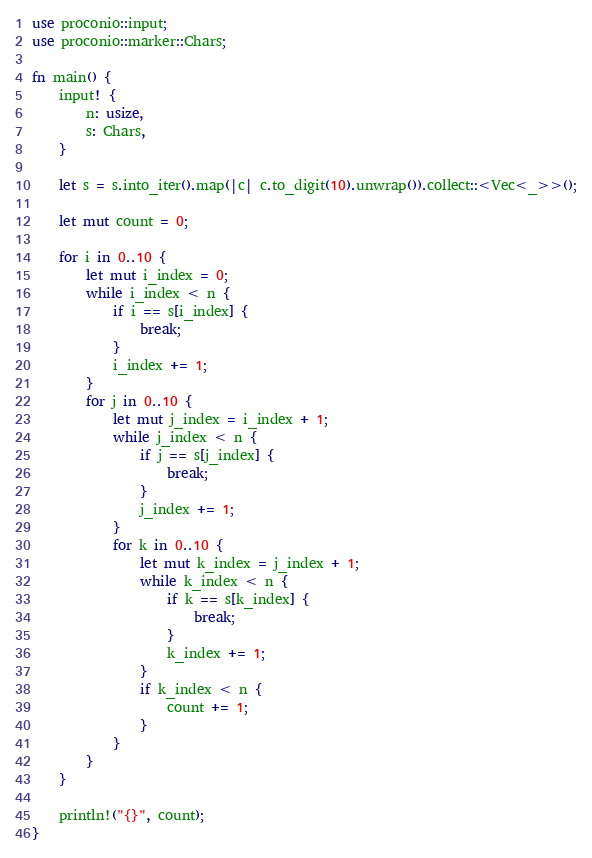Convert code to text. <code><loc_0><loc_0><loc_500><loc_500><_Rust_>use proconio::input;
use proconio::marker::Chars;

fn main() {
    input! {
        n: usize,
        s: Chars,
    }

    let s = s.into_iter().map(|c| c.to_digit(10).unwrap()).collect::<Vec<_>>();

    let mut count = 0;

    for i in 0..10 {
        let mut i_index = 0;
        while i_index < n {
            if i == s[i_index] {
                break;
            }
            i_index += 1;
        }
        for j in 0..10 {
            let mut j_index = i_index + 1;
            while j_index < n {
                if j == s[j_index] {
                    break;
                }
                j_index += 1;
            }
            for k in 0..10 {
                let mut k_index = j_index + 1;
                while k_index < n {
                    if k == s[k_index] {
                        break;
                    }
                    k_index += 1;
                }
                if k_index < n {
                    count += 1;
                }
            }
        }
    }

    println!("{}", count);
}
</code> 